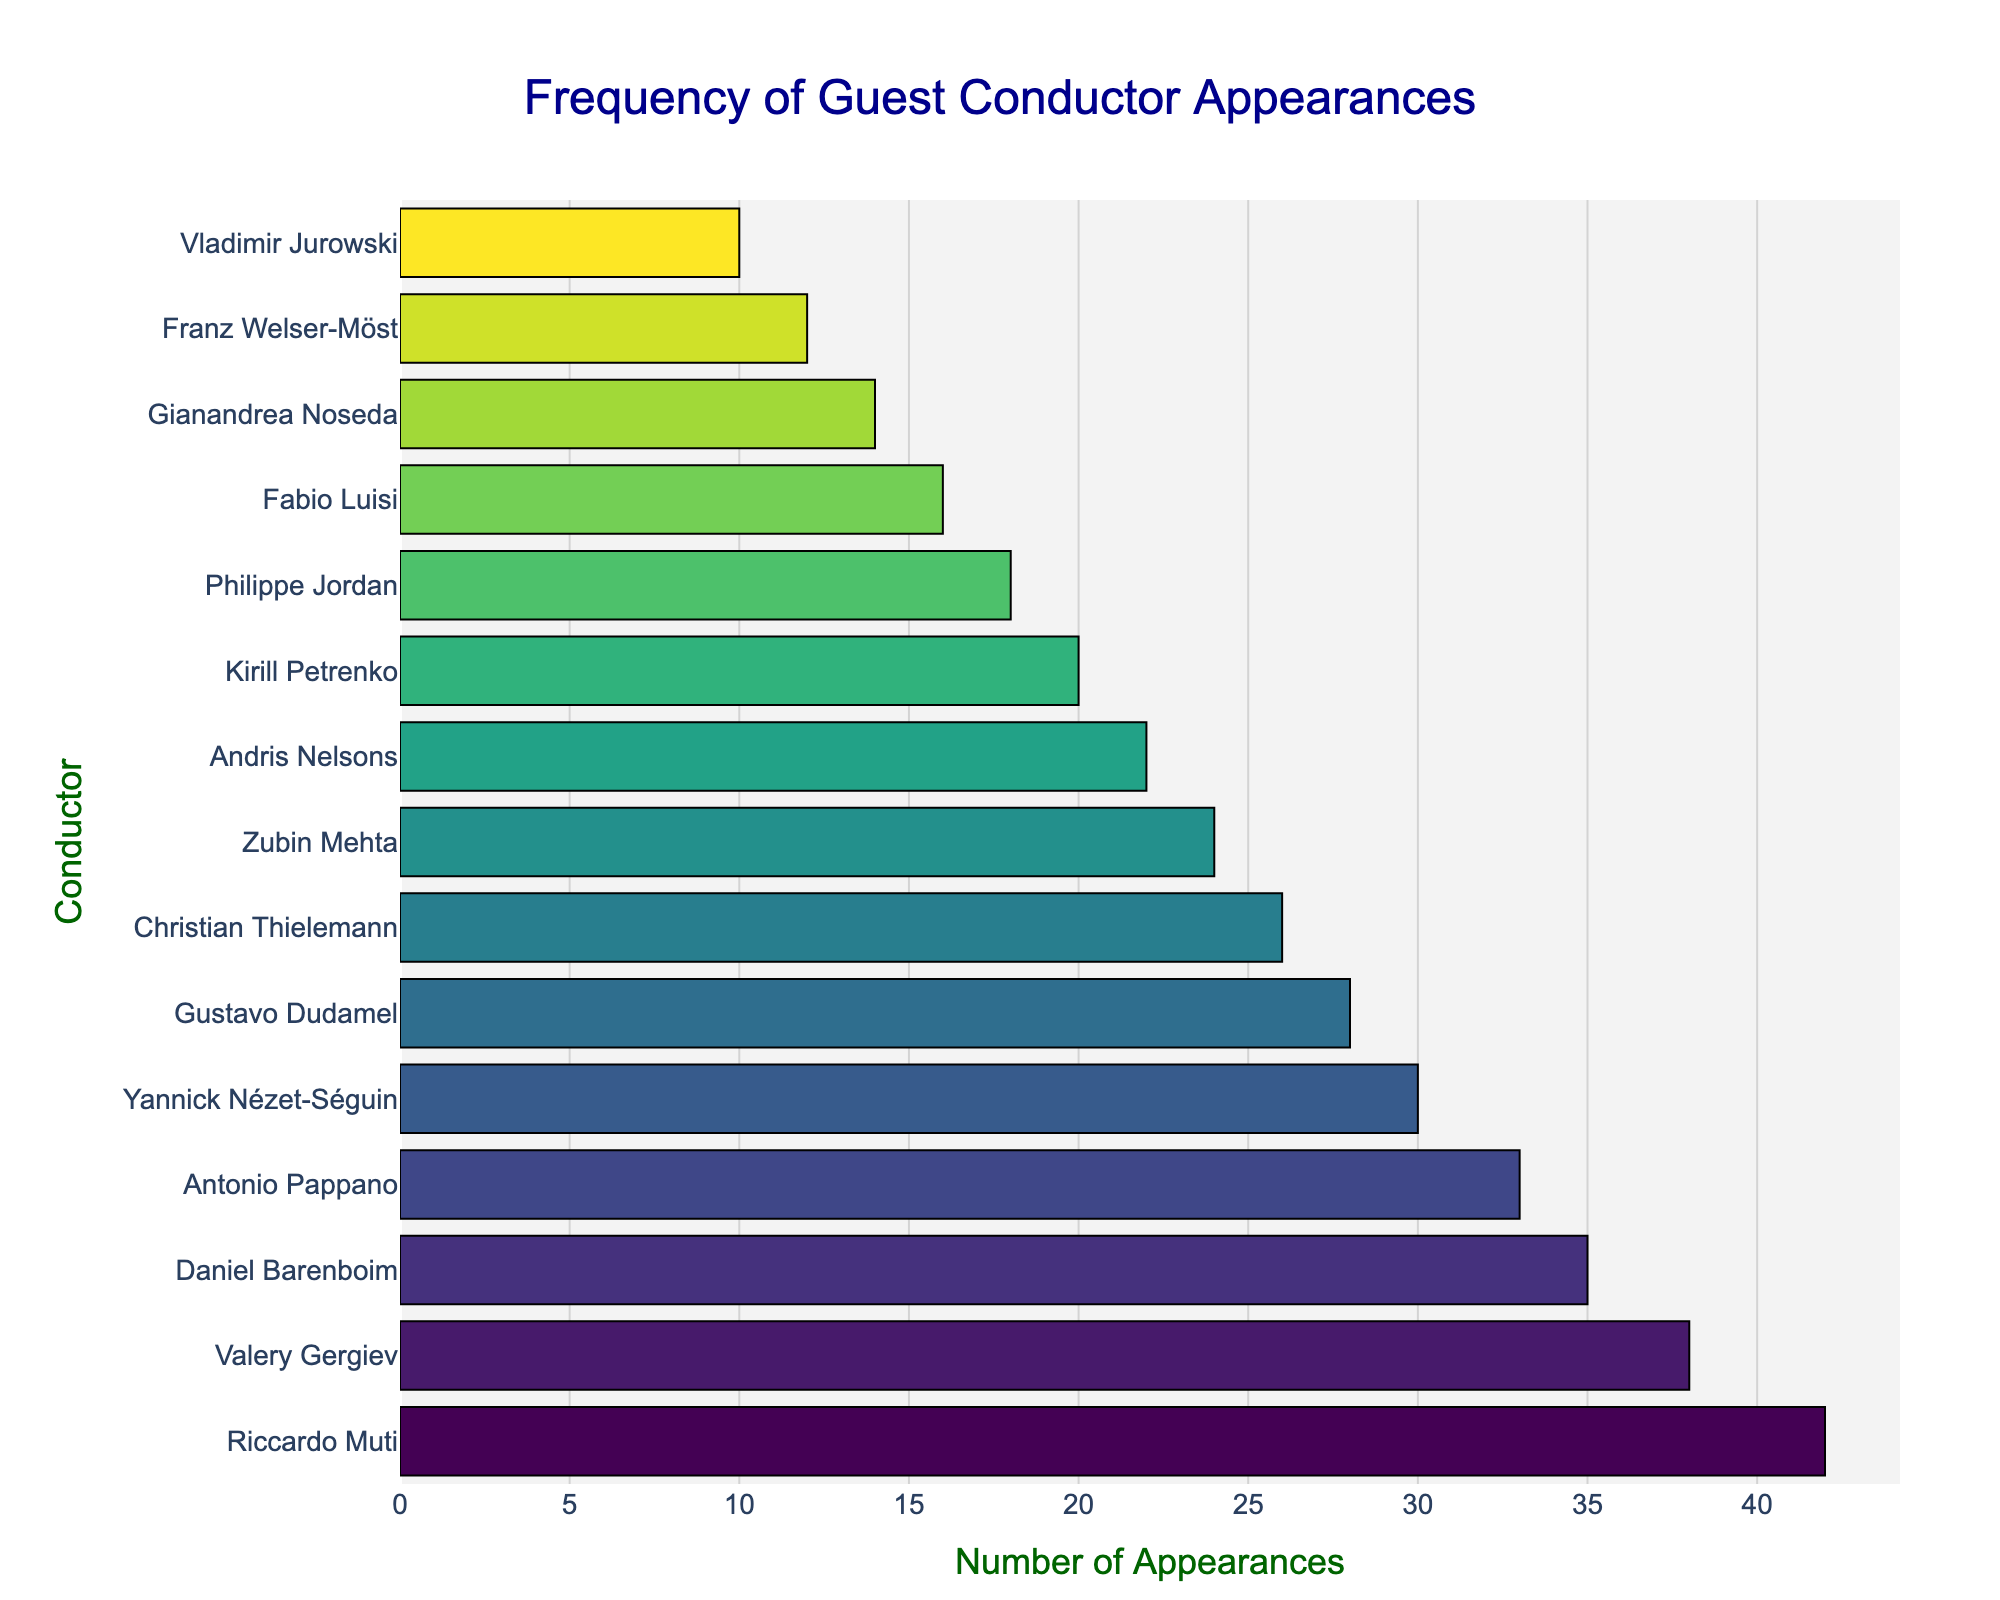what is the total number of appearances for Riccardo Muti and Valery Gergiev? First, identify the appearances of Riccardo Muti, which is 42, and Valery Gergiev, which is 38 from the figure. Sum the two values: 42 + 38.
Answer: 80 Is Daniel Barenboim's number of guest appearances more or less than Antonio Pappano's? Identify the number of appearances for Daniel Barenboim and Antonio Pappano from the figure. Barenboim has 35 and Pappano has 33. Compare the two values: 35 is more than 33.
Answer: More Which conductor has more appearances: Yannick Nézet-Séguin or Gustavo Dudamel? Identify appearances for Yannick Nézet-Séguin (30) and Gustavo Dudamel (28) from the figure. Compare their values: 30 is more than 28.
Answer: Yannick Nézet-Séguin What is the appearance difference between Zubin Mehta and Andris Nelsons? Identify the appearances of Zubin Mehta (24) and Andris Nelsons (22) from the figure. Subtract the smaller number from the larger: 24 - 22.
Answer: 2 What is the sum of appearances for the bottom three conductors on the list? Identify the appearances of the bottom three conductors: Gianandrea Noseda (14), Franz Welser-Möst (12), Vladimir Jurowski (10). Sum the values: 14 + 12 + 10.
Answer: 36 How many more appearances does Kirill Petrenko have compared to Philippe Jordan? Identify appearances for Kirill Petrenko (20) and Philippe Jordan (18) from the figure. Subtract to find the difference: 20 - 18.
Answer: 2 Is the bar representing Riccardo Muti visually longer than the bar representing Fabio Luisi? Observe the lengths of the bars corresponding to Riccardo Muti and Fabio Luisi in the figure. Since Muti has 42 appearances and Luisi has 16, Muti's bar is visually longer.
Answer: Yes Which conductor has fewer appearances: Christian Thielemann or Zubin Mehta? Identify appearances for Christian Thielemann (26) and Zubin Mehta (24) from the figure. Compare their values: 24 is less than 26.
Answer: Zubin Mehta 